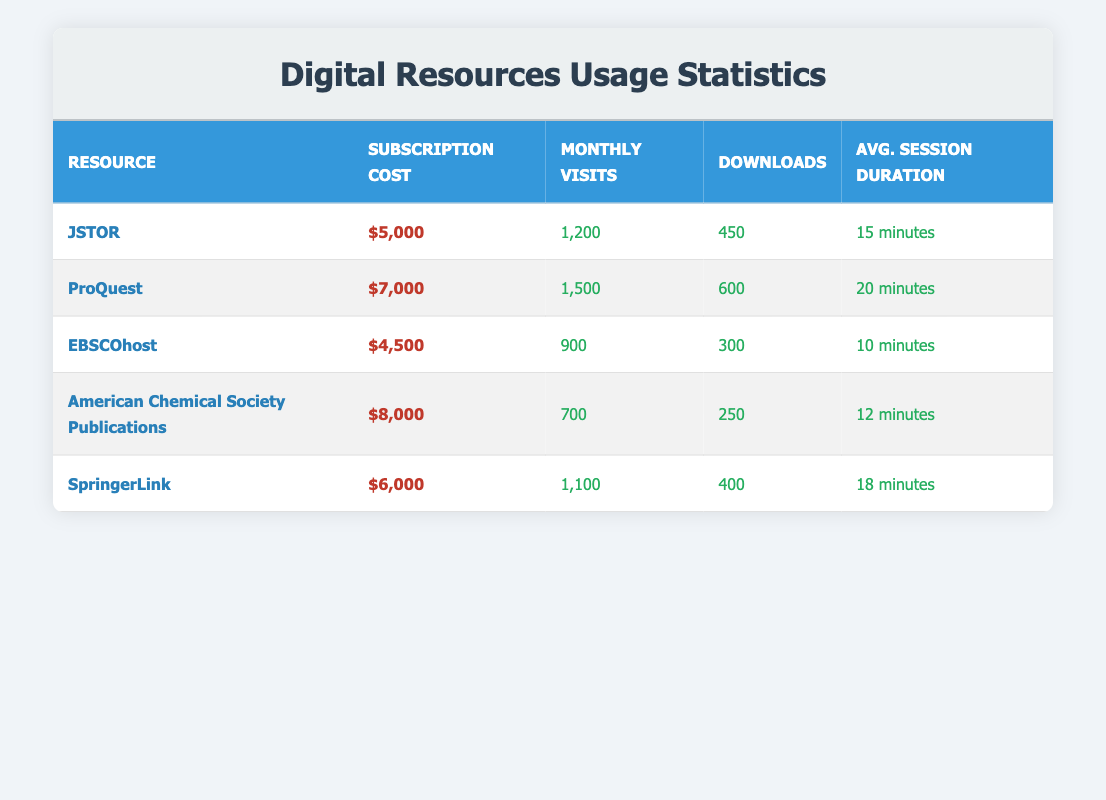What is the subscription cost for EBSCOhost? The subscription cost for EBSCOhost is directly listed in the table under the column "Subscription Cost," which states $4,500.
Answer: $4,500 How many monthly visits does ProQuest receive? ProQuest's monthly visits are shown in the row corresponding to ProQuest under the "Monthly Visits" column, which indicates 1,500 visits.
Answer: 1,500 Which resource has the highest number of downloads? To find the resource with the highest number of downloads, we look at the "Downloads" column. ProQuest has 600 downloads which is higher than all other resources.
Answer: ProQuest Is the average session duration for SpringerLink greater than 15 minutes? The average session duration for SpringerLink is 18 minutes, which is greater than 15 minutes, making this statement true.
Answer: Yes Calculate the total subscription cost for all resources listed. To calculate the total subscription cost, we sum all the subscription costs: 5000 + 7000 + 4500 + 8000 + 6000 = 30500.
Answer: 30,500 Which resource has the lowest average session duration? The average session duration can be compared in the "Avg. Session Duration" column. EBSCOhost has the lowest at 10 minutes.
Answer: EBSCOhost Does American Chemical Society Publications have more monthly visits than JSTOR? American Chemical Society Publications has 700 monthly visits, while JSTOR has 1,200 visits. Since 700 is less than 1,200, the statement is false.
Answer: No Between which two resources is the difference in downloads the largest? We look at the downloads: JSTOR (450), ProQuest (600), EBSCOhost (300), ACS Publications (250), and SpringerLink (400). The largest difference is between ProQuest (600) and EBSCOhost (300): 600 - 300 = 300.
Answer: ProQuest and EBSCOhost What is the average number of monthly visits across all resources? The average can be calculated by summing the monthly visits: 1200 + 1500 + 900 + 700 + 1100 = 4400, and dividing by the number of resources (5): 4400 / 5 = 880.
Answer: 880 